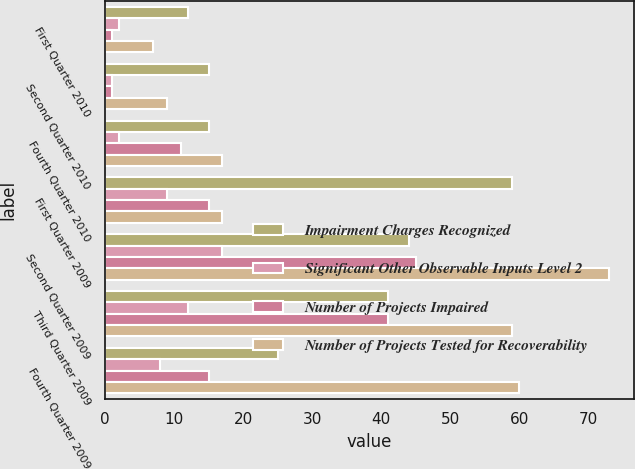Convert chart. <chart><loc_0><loc_0><loc_500><loc_500><stacked_bar_chart><ecel><fcel>First Quarter 2010<fcel>Second Quarter 2010<fcel>Fourth Quarter 2010<fcel>First Quarter 2009<fcel>Second Quarter 2009<fcel>Third Quarter 2009<fcel>Fourth Quarter 2009<nl><fcel>Impairment Charges Recognized<fcel>12<fcel>15<fcel>15<fcel>59<fcel>44<fcel>41<fcel>25<nl><fcel>Significant Other Observable Inputs Level 2<fcel>2<fcel>1<fcel>2<fcel>9<fcel>17<fcel>12<fcel>8<nl><fcel>Number of Projects Impaired<fcel>1<fcel>1<fcel>11<fcel>15<fcel>45<fcel>41<fcel>15<nl><fcel>Number of Projects Tested for Recoverability<fcel>7<fcel>9<fcel>17<fcel>17<fcel>73<fcel>59<fcel>60<nl></chart> 